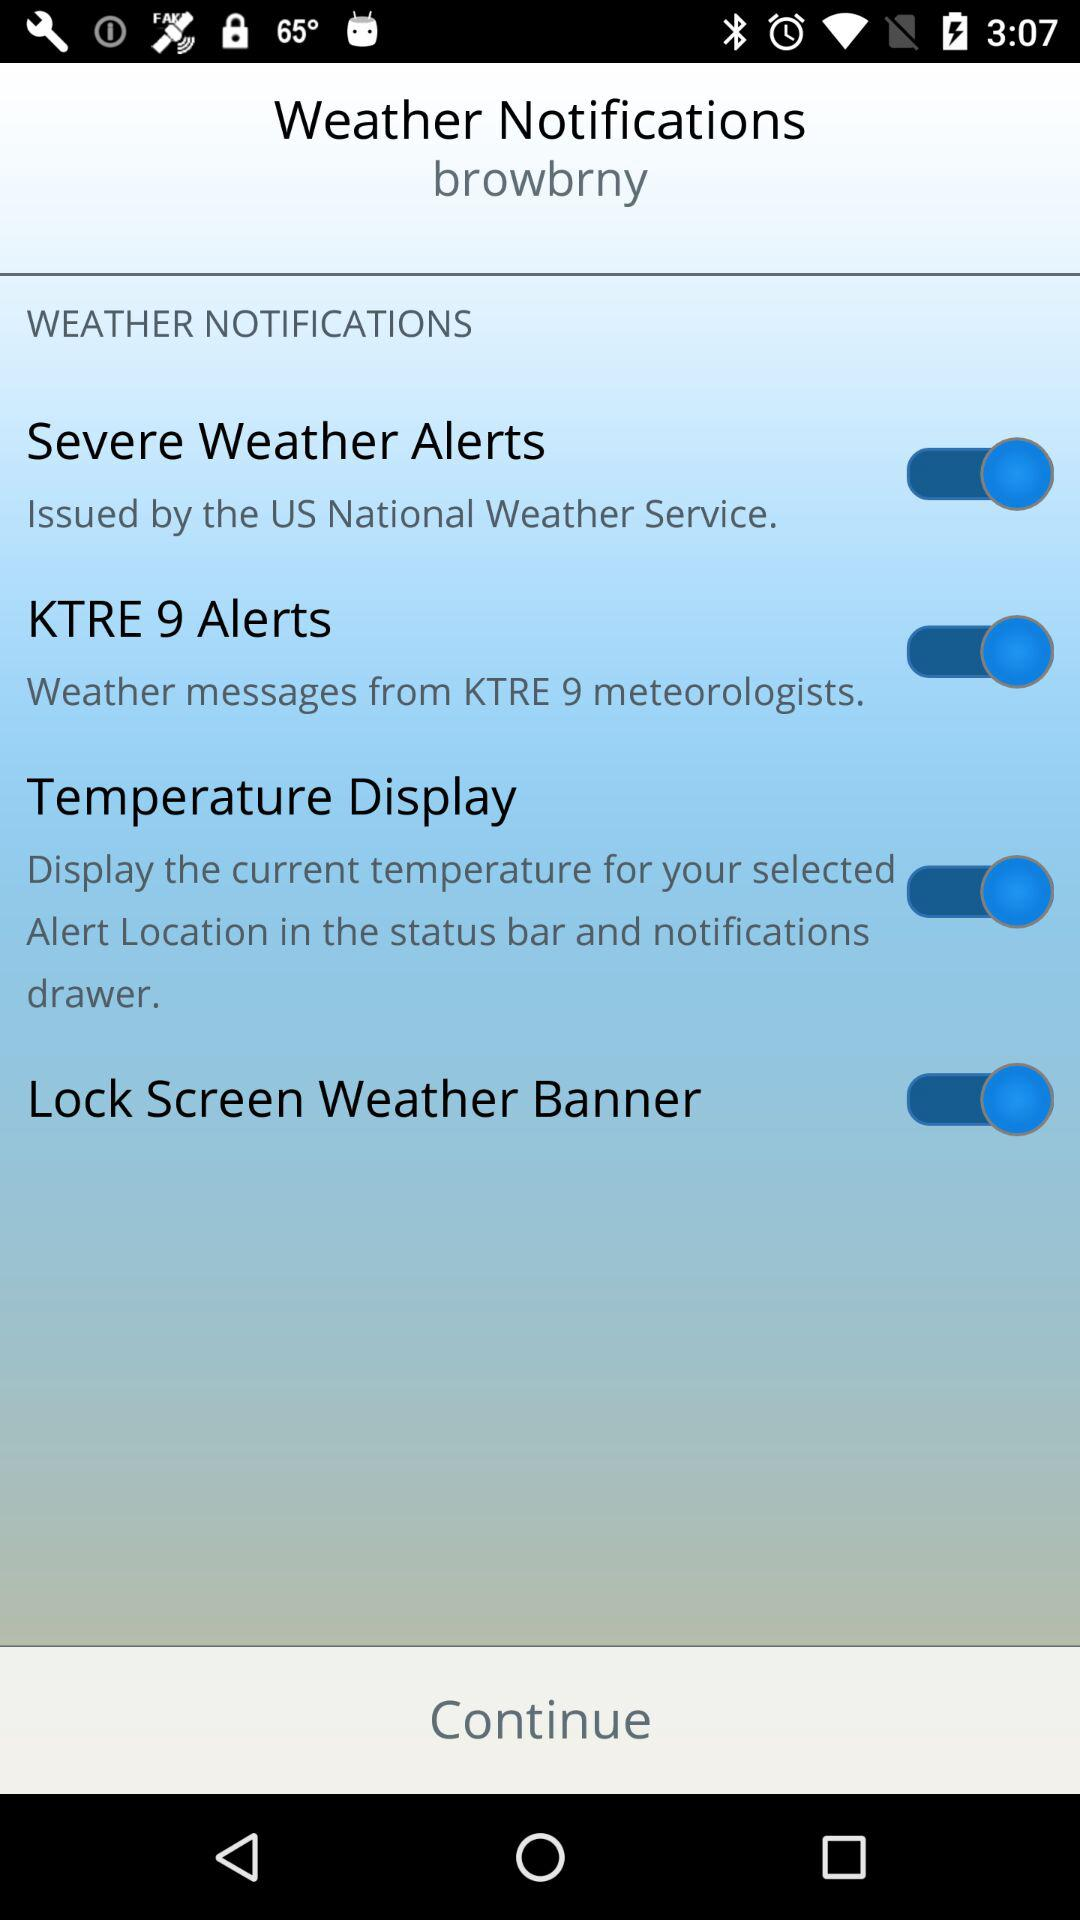What is the status of "Temperature Display"? The status is "on". 